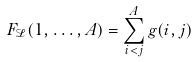Convert formula to latex. <formula><loc_0><loc_0><loc_500><loc_500>F _ { \mathcal { L } } ( 1 , \dots , A ) = \sum _ { i < j } ^ { A } g ( i , j )</formula> 